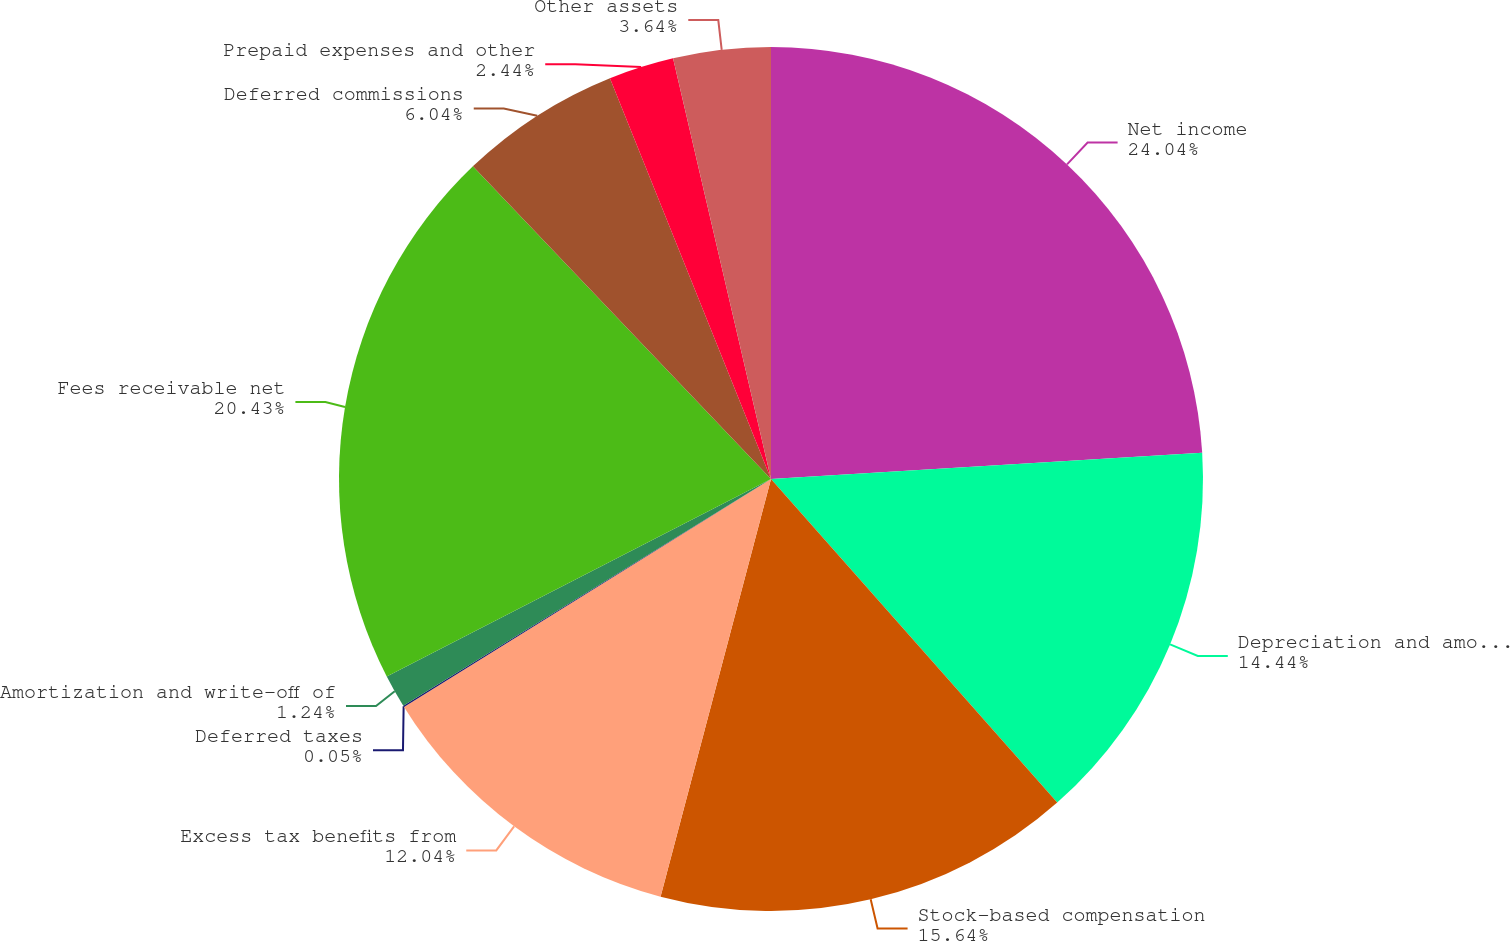<chart> <loc_0><loc_0><loc_500><loc_500><pie_chart><fcel>Net income<fcel>Depreciation and amortization<fcel>Stock-based compensation<fcel>Excess tax benefits from<fcel>Deferred taxes<fcel>Amortization and write-off of<fcel>Fees receivable net<fcel>Deferred commissions<fcel>Prepaid expenses and other<fcel>Other assets<nl><fcel>24.03%<fcel>14.44%<fcel>15.64%<fcel>12.04%<fcel>0.05%<fcel>1.24%<fcel>20.43%<fcel>6.04%<fcel>2.44%<fcel>3.64%<nl></chart> 